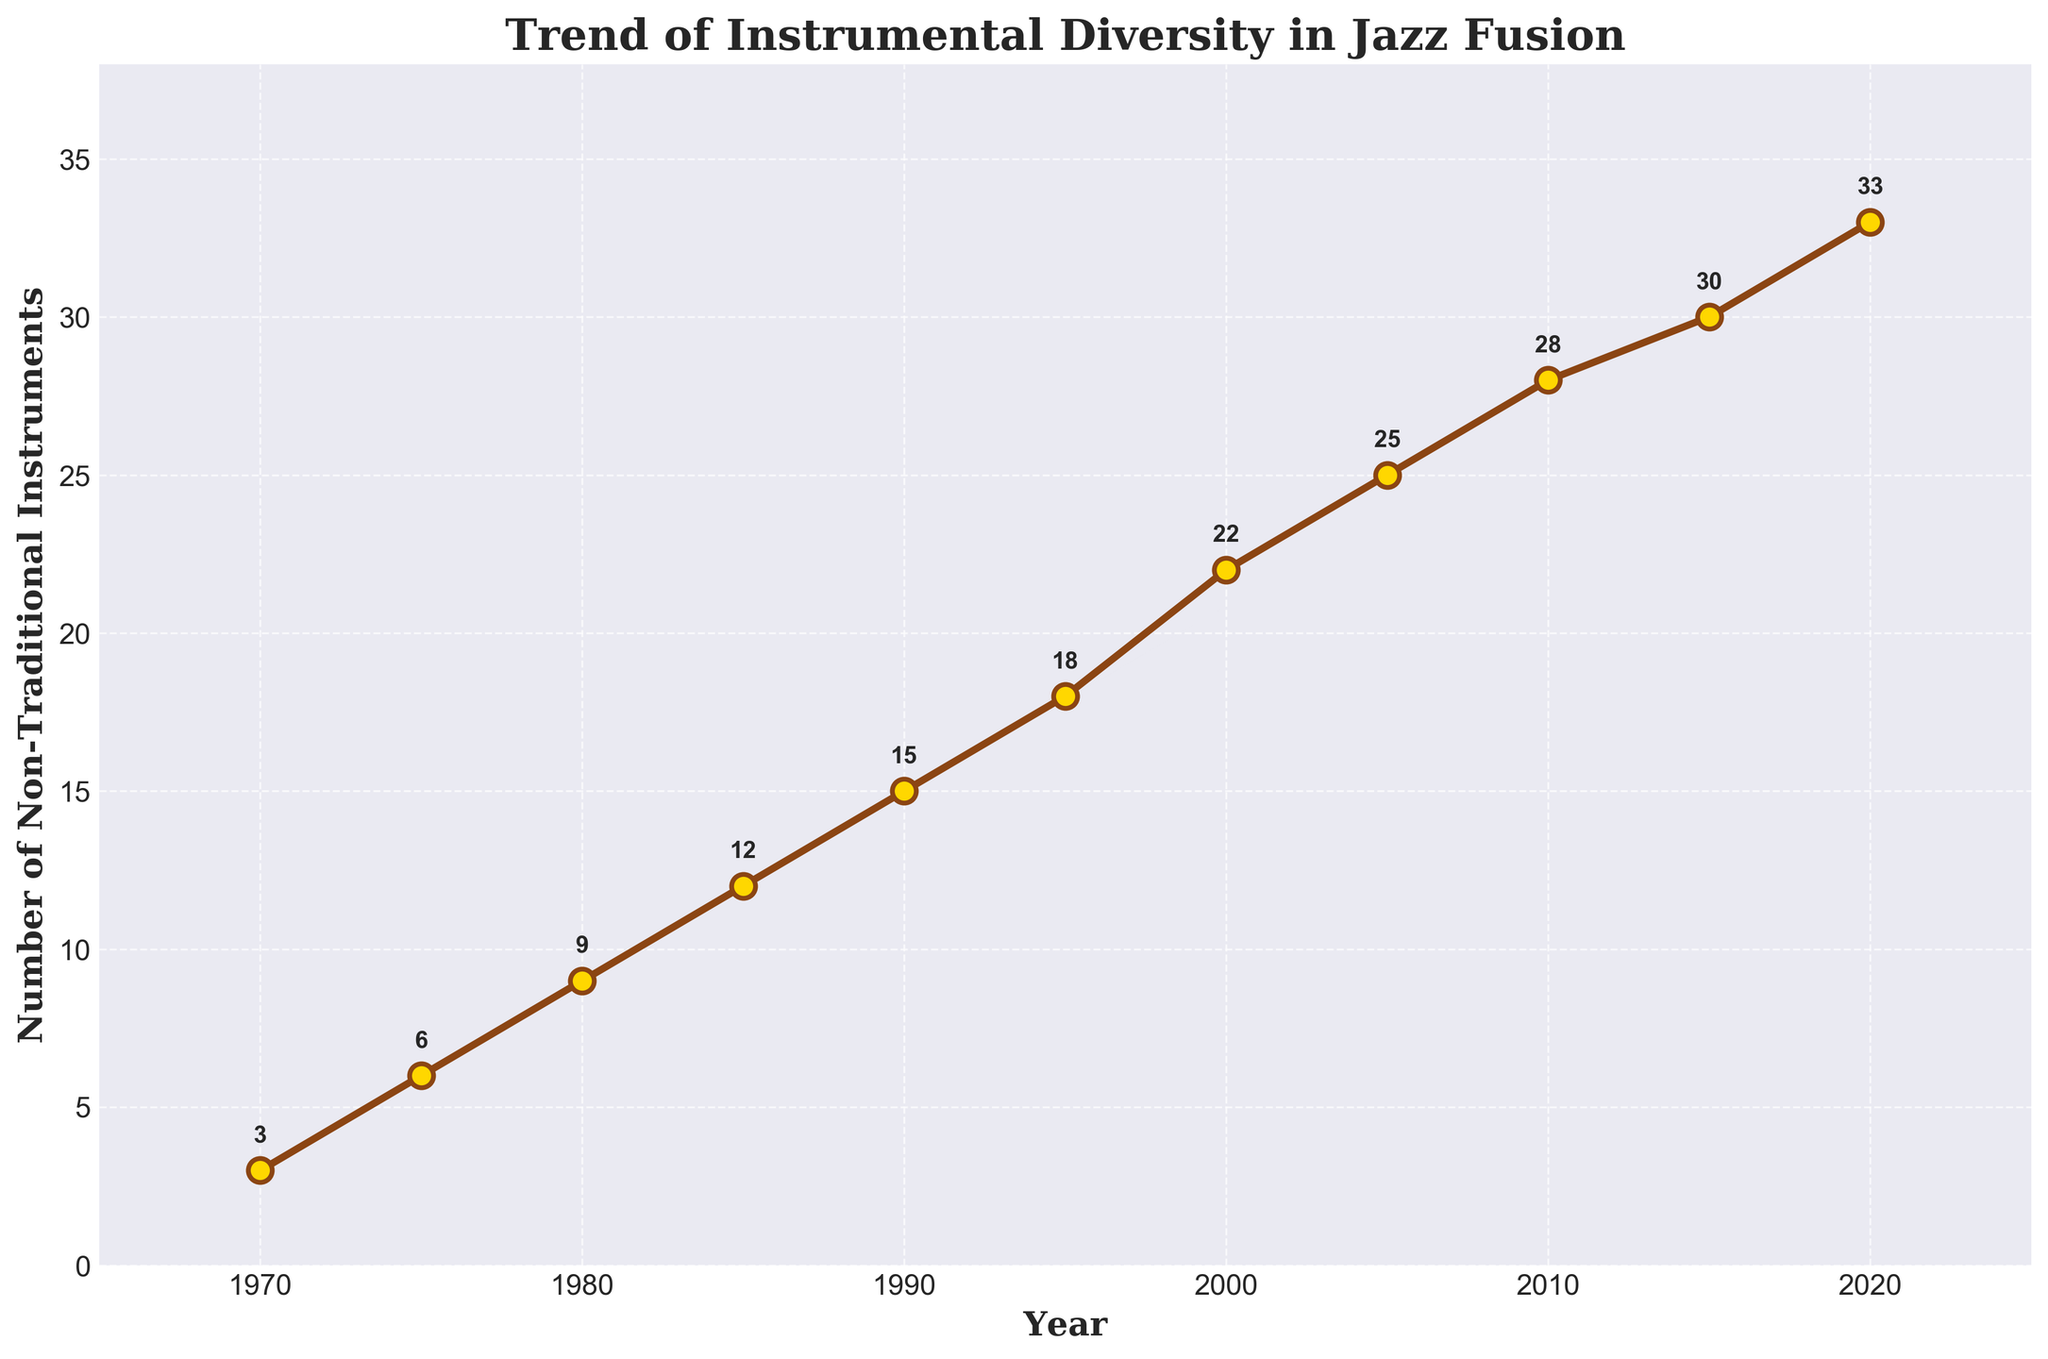What is the trend in the number of non-traditional instruments incorporated in jazz fusion from 1970 to 2020? The line chart shows a steady increase in the number of non-traditional instruments incorporated in jazz fusion from 3 in 1970 to 33 in 2020. This indicates a growing trend over the 50-year period.
Answer: Increasing trend How many non-traditional instruments were incorporated in jazz fusion in 1980? Referring to the figure, in the year 1980, the number of non-traditional instruments incorporated in jazz fusion is annotated as 9.
Answer: 9 By how much did the number of non-traditional instruments increase between 1975 and 2005? The figure shows that in 1975, there were 6 non-traditional instruments, and in 2005, there were 25. The increase is calculated by subtracting 6 from 25: \(25 - 6 = 19\).
Answer: 19 What is the average number of non-traditional instruments incorporated per decade from 1970 to 2020? First, sum the number of non-traditional instruments for each decade (from the given data points): \(3 + 6 + 9 + 12 + 15 + 18 + 22 + 25 + 28 + 30 + 33 = 201\). There are 11 data points representing each year in the periods provided. The average is \(201 / 11\).
Answer: 18.27 In which decade did the number of non-traditional instruments see the highest increase? By examining the annotations, the largest decade-to-decade increases are:
1970-1980: \(9 - 3 = 6\),
1980-1990: \(15 - 9 = 6\),
1990-2000: \(22 - 15 = 7\),
2000-2010: \(28 - 22 = 6\),
2010-2020: \(33 - 28 = 5\). 
The highest increase of 7 occurred between 1990 and 2000.
Answer: 1990-2000 Which year marks the midpoint (median) in the range of your data, and how many non-traditional instruments were incorporated that year? The range of years is from 1970 to 2020. The midpoint year, when sorted chronologically, is 1995 (the 6th value in a list of 11 years). In 1995, the figure annotates 18 non-traditional instruments.
Answer: 1995; 18 How does the number of non-traditional instruments in 2010 compare to those in 1985? Referring to the annotations, in 2010, there were 28 non-traditional instruments and in 1985, there were 12. Thus, there are \(28 - 12 = 16\) more non-traditional instruments in 2010 compared to 1985.
Answer: 16 more What is the color of the marker used to indicate data points on the line chart? The visual inspection of the figure shows that the markers are gold in color with a brown edge.
Answer: Gold with brown edge What was the minimum and maximum number of non-traditional instruments from 1970 to 2020? The figure shows the minimum number was 3 in 1970 and the maximum was 33 in 2020.
Answer: 3 (min), 33 (max) By how much did the number of non-traditional instruments increase from 1990 to 1995? The annotations show that in 1990, there were 15 non-traditional instruments, and in 1995, there were 18. The increase is \(18 - 15\).
Answer: 3 